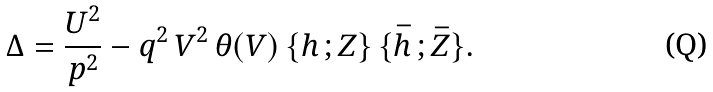Convert formula to latex. <formula><loc_0><loc_0><loc_500><loc_500>\Delta = \frac { U ^ { 2 } } { p ^ { 2 } } - q ^ { 2 } \, V ^ { 2 } \, \theta ( V ) \, \{ h \, ; Z \} \, \{ \bar { h } \, ; \bar { Z } \} .</formula> 